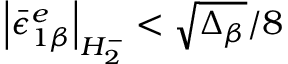<formula> <loc_0><loc_0><loc_500><loc_500>\left | { \bar { \epsilon } } _ { 1 \beta } ^ { e } \right | _ { H _ { 2 } ^ { - } } < \sqrt { \Delta _ { \beta } } / 8</formula> 